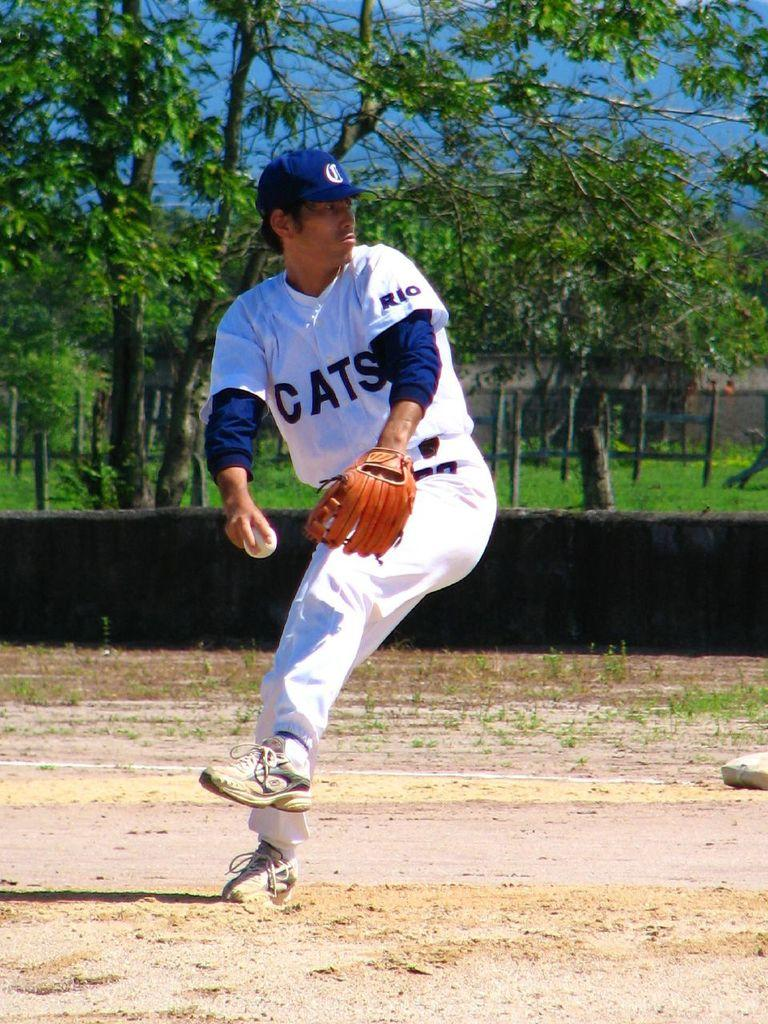<image>
Render a clear and concise summary of the photo. A man in a uniform with the team name Cats on it with a glove and baseball in hand. 